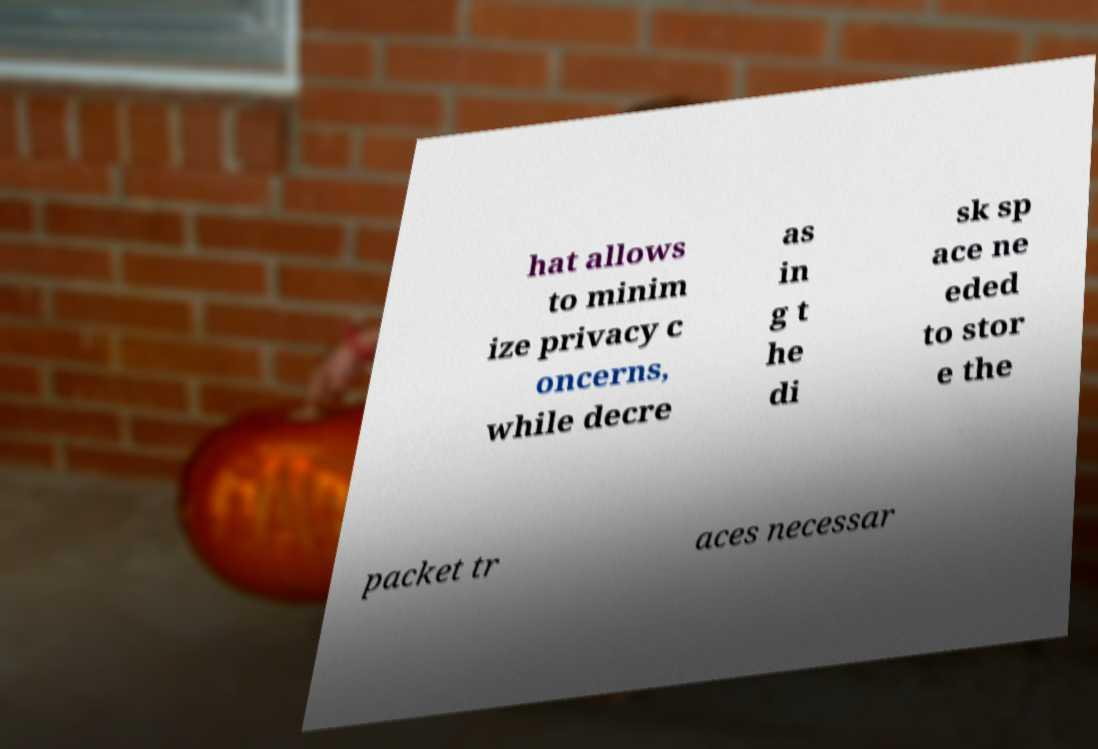Please identify and transcribe the text found in this image. hat allows to minim ize privacy c oncerns, while decre as in g t he di sk sp ace ne eded to stor e the packet tr aces necessar 